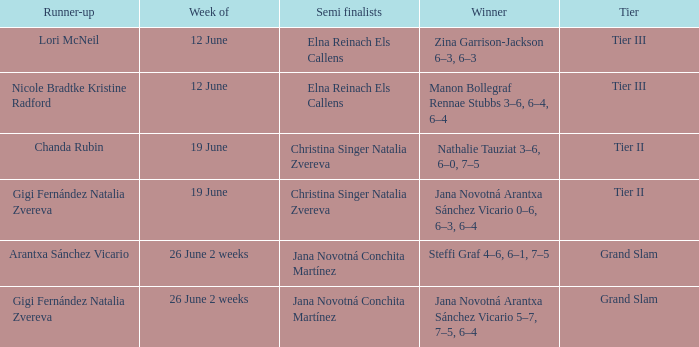Could you parse the entire table as a dict? {'header': ['Runner-up', 'Week of', 'Semi finalists', 'Winner', 'Tier'], 'rows': [['Lori McNeil', '12 June', 'Elna Reinach Els Callens', 'Zina Garrison-Jackson 6–3, 6–3', 'Tier III'], ['Nicole Bradtke Kristine Radford', '12 June', 'Elna Reinach Els Callens', 'Manon Bollegraf Rennae Stubbs 3–6, 6–4, 6–4', 'Tier III'], ['Chanda Rubin', '19 June', 'Christina Singer Natalia Zvereva', 'Nathalie Tauziat 3–6, 6–0, 7–5', 'Tier II'], ['Gigi Fernández Natalia Zvereva', '19 June', 'Christina Singer Natalia Zvereva', 'Jana Novotná Arantxa Sánchez Vicario 0–6, 6–3, 6–4', 'Tier II'], ['Arantxa Sánchez Vicario', '26 June 2 weeks', 'Jana Novotná Conchita Martínez', 'Steffi Graf 4–6, 6–1, 7–5', 'Grand Slam'], ['Gigi Fernández Natalia Zvereva', '26 June 2 weeks', 'Jana Novotná Conchita Martínez', 'Jana Novotná Arantxa Sánchez Vicario 5–7, 7–5, 6–4', 'Grand Slam']]} In which week is the winner listed as Jana Novotná Arantxa Sánchez Vicario 5–7, 7–5, 6–4? 26 June 2 weeks. 